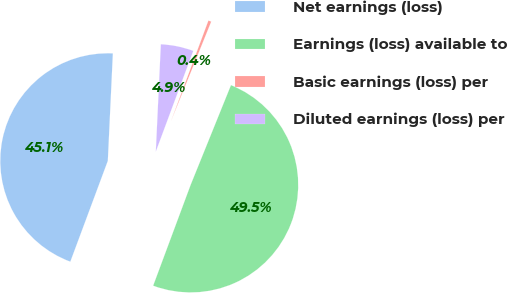Convert chart to OTSL. <chart><loc_0><loc_0><loc_500><loc_500><pie_chart><fcel>Net earnings (loss)<fcel>Earnings (loss) available to<fcel>Basic earnings (loss) per<fcel>Diluted earnings (loss) per<nl><fcel>45.08%<fcel>49.55%<fcel>0.45%<fcel>4.92%<nl></chart> 